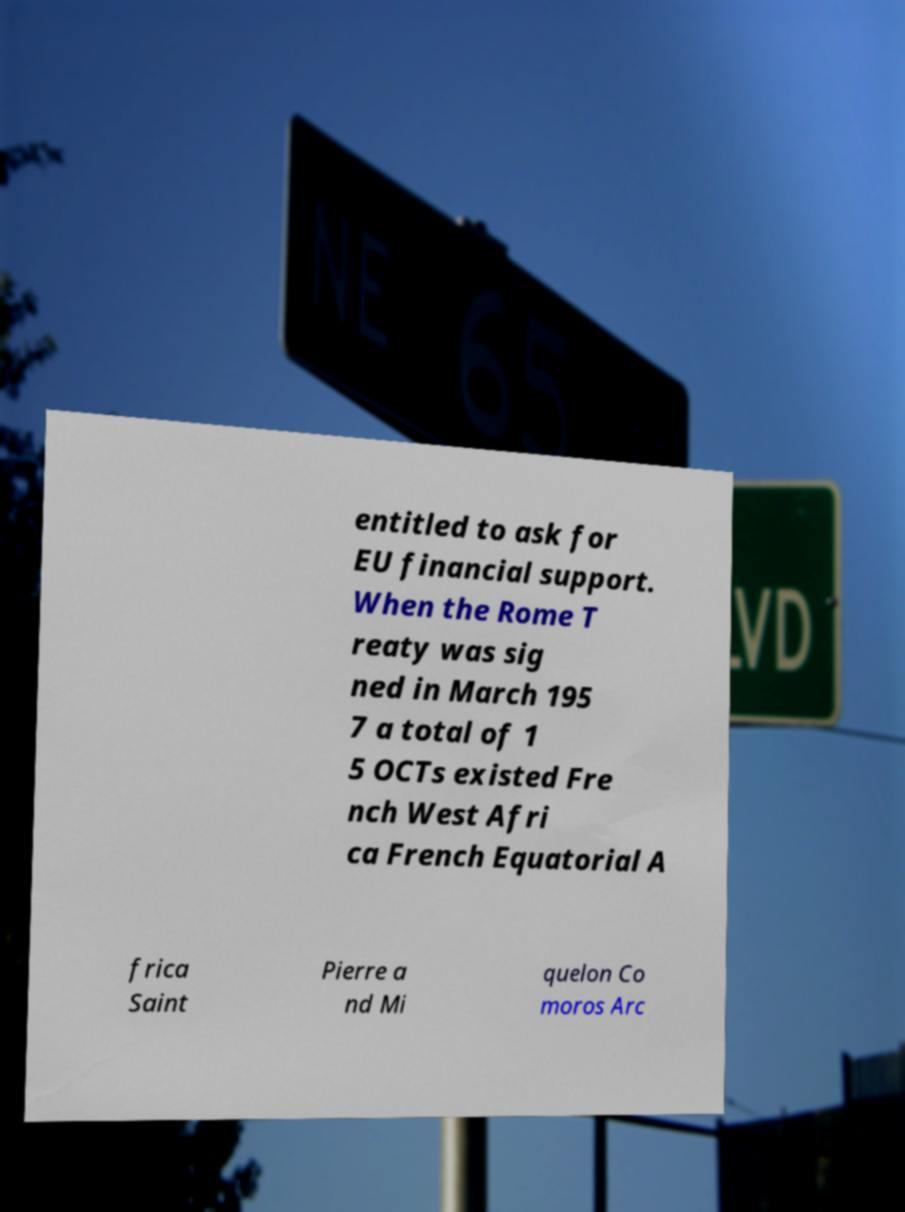There's text embedded in this image that I need extracted. Can you transcribe it verbatim? entitled to ask for EU financial support. When the Rome T reaty was sig ned in March 195 7 a total of 1 5 OCTs existed Fre nch West Afri ca French Equatorial A frica Saint Pierre a nd Mi quelon Co moros Arc 